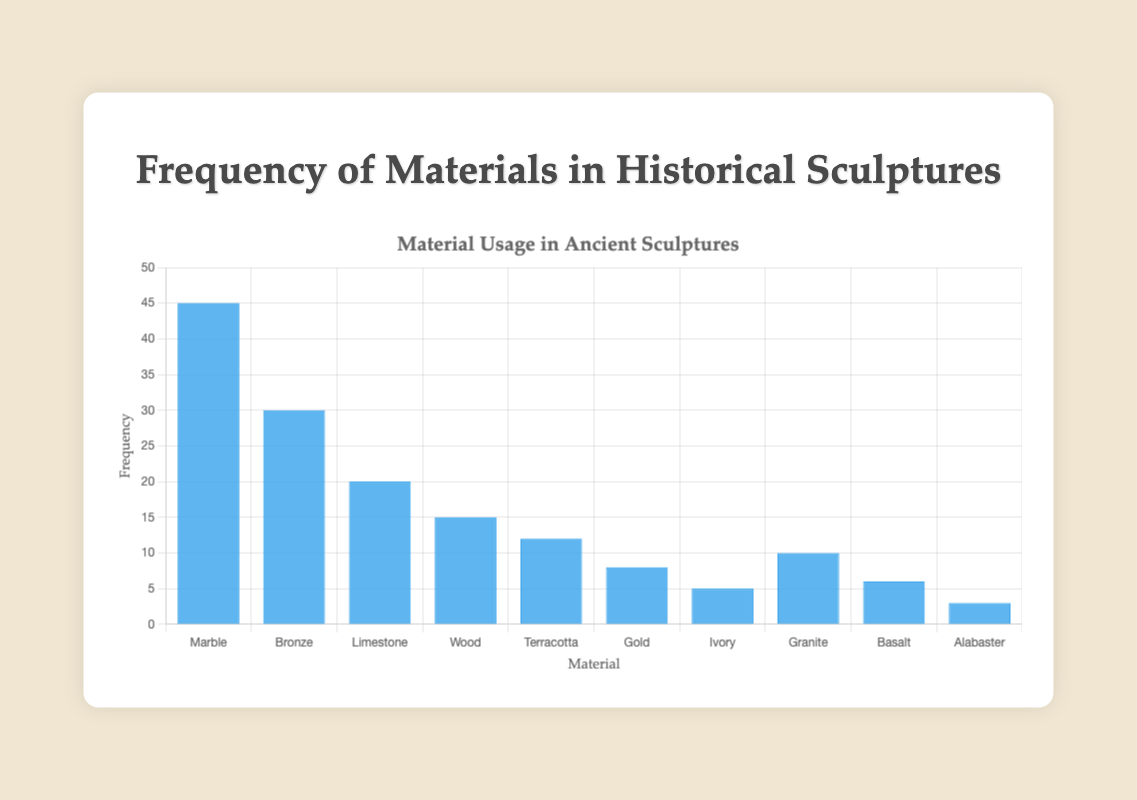What material is used most frequently in historical sculptures? The bar chart shows different materials represented by blue bars. The material with the highest bar indicates the most frequent use. Marble has the highest bar, indicating it is used most frequently.
Answer: Marble Which two materials have the closest frequency of use? By examining the heights of the bars, we can see that Gold and Basalt have frequencies that are relatively close to each other, with values of 8 and 6 respectively.
Answer: Gold and Basalt How many more times is Marble used compared to Ivory? The frequency values for Marble and Ivory are 45 and 5 respectively. Subtracting these values (45 - 5) gives the difference in usage.
Answer: 40 What is the average frequency of the materials listed? To find the average frequency, sum up the frequencies of all materials (45+30+20+15+12+8+5+10+6+3 = 154). Divide this sum by the number of materials (10). Thus, the average frequency is 154/10.
Answer: 15.4 Does Limestone have a higher frequency than Wood? By comparing the bar heights, Limestone has a frequency of 20 while Wood has a frequency of 15. Thus, Limestone has a higher frequency.
Answer: Yes What is the sum of the frequencies for Bronze and Granite? The frequency values for Bronze and Granite are 30 and 10 respectively. Adding these values (30 + 10) gives the total frequency.
Answer: 40 Which material has the second-lowest frequency of use? By observing the heights of the bars, Alabaster has the lowest frequency (3). The next lowest frequency is 5, corresponding to Ivory.
Answer: Ivory What is the total frequency of materials that have a count of less than 10? Materials with frequencies less than 10 are Gold (8), Ivory (5), Basalt (6), and Alabaster (3). Summing these frequencies (8 + 5 + 6 + 3) gives the total.
Answer: 22 Is the frequency of Limestone closer to the frequency of Granite than it is to the frequency of Bronze? Limestone has a frequency of 20. The frequencies of Granite and Bronze are 10 and 30 respectively. The differences are:
Answer: No How do the frequencies of Wood and Terracotta compare? The frequencies of Wood and Terracotta are shown by the heights of their bars, which are 15 and 12 respectively. Wood's frequency is higher by 3.
Answer: Wood 